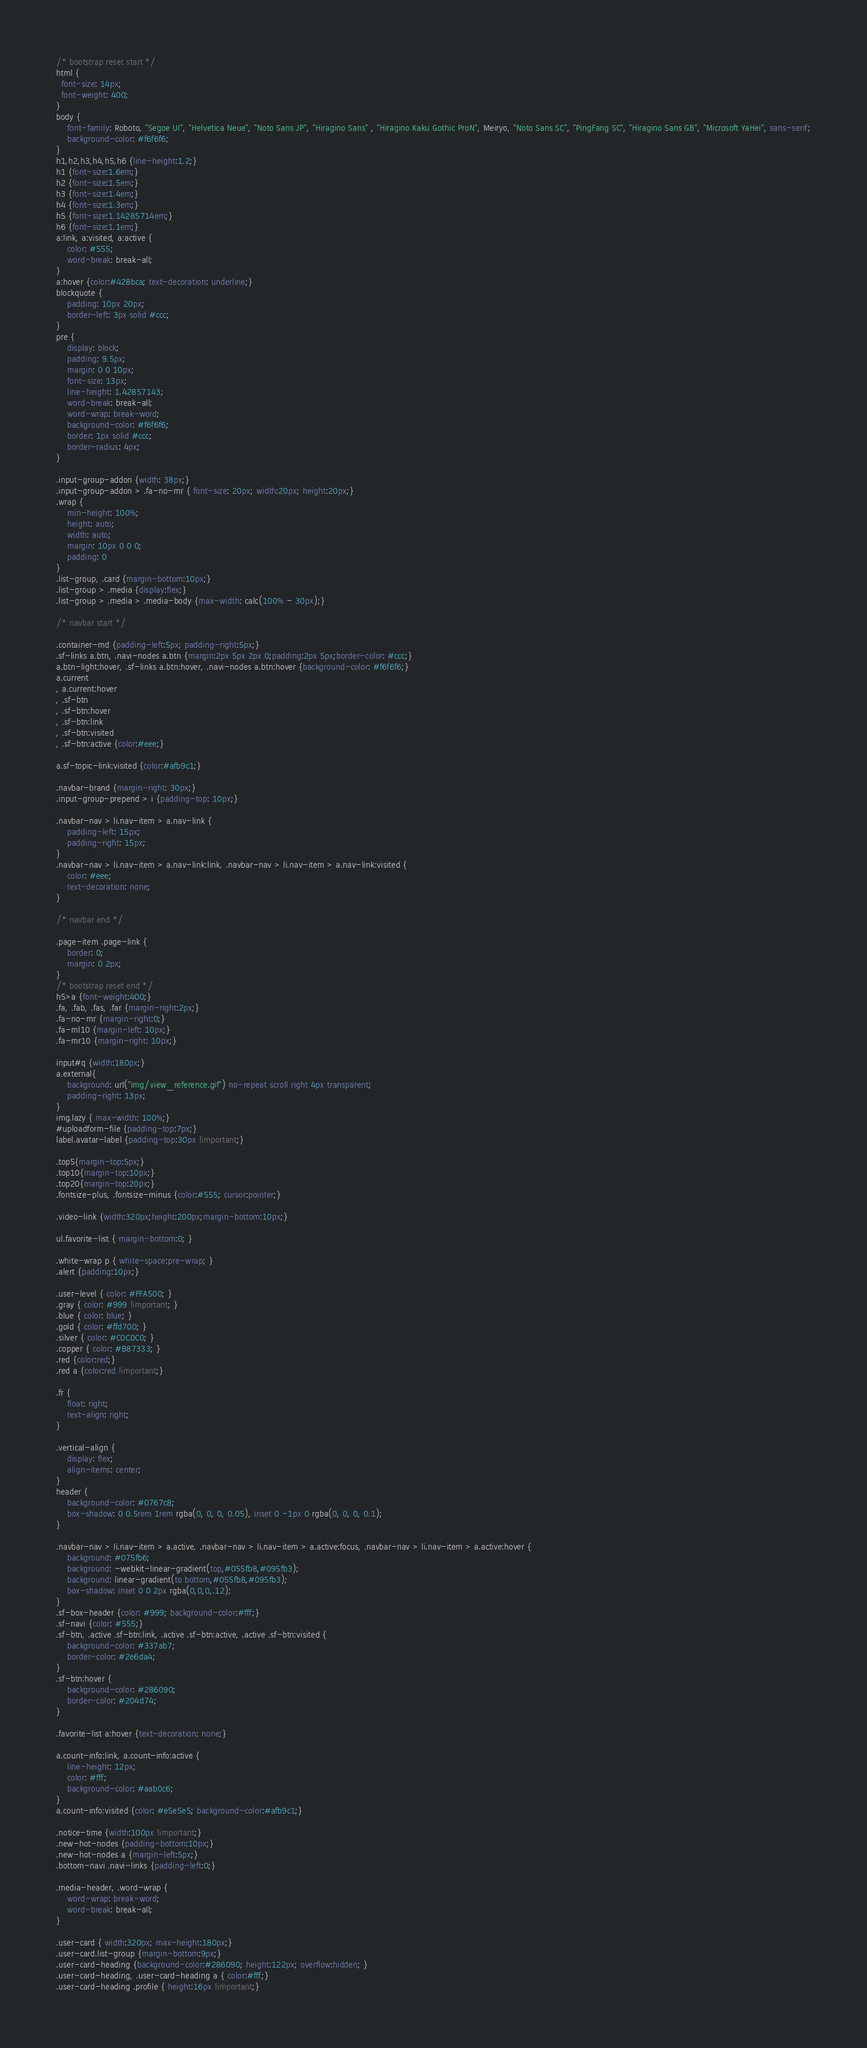<code> <loc_0><loc_0><loc_500><loc_500><_CSS_>/* bootstrap reset start */
html {
  font-size: 14px; 
  font-weight: 400; 
} 
body {
    font-family: Roboto, "Segoe UI", "Helvetica Neue", "Noto Sans JP", "Hiragino Sans" , "Hiragino Kaku Gothic ProN", Meiryo, "Noto Sans SC", "PingFang SC", "Hiragino Sans GB", "Microsoft YaHei", sans-serif;
    background-color: #f6f6f6;
}
h1,h2,h3,h4,h5,h6 {line-height:1.2;}
h1 {font-size:1.6em;}
h2 {font-size:1.5em;}
h3 {font-size:1.4em;}
h4 {font-size:1.3em;}
h5 {font-size:1.14285714em;}
h6 {font-size:1.1em;}
a:link, a:visited, a:active {
    color: #555;
    word-break: break-all;
}
a:hover {color:#428bca; text-decoration: underline;}
blockquote {
    padding: 10px 20px;
    border-left: 3px solid #ccc;
}
pre {
    display: block;
    padding: 9.5px;
    margin: 0 0 10px;
    font-size: 13px;
    line-height: 1.42857143;
    word-break: break-all;
    word-wrap: break-word;
    background-color: #f6f6f6;
    border: 1px solid #ccc;
    border-radius: 4px;
}

.input-group-addon {width: 38px;}
.input-group-addon > .fa-no-mr { font-size: 20px; width:20px; height:20px;}
.wrap {
    min-height: 100%;
    height: auto;
    width: auto;
    margin: 10px 0 0 0;
    padding: 0
}
.list-group, .card {margin-bottom:10px;}
.list-group > .media {display:flex;}
.list-group > .media > .media-body {max-width: calc(100% - 30px);}

/* navbar start */

.container-md {padding-left:5px; padding-right:5px;}
.sf-links a.btn, .navi-nodes a.btn {margin:2px 5px 2px 0;padding:2px 5px;border-color: #ccc;}
a.btn-light:hover, .sf-links a.btn:hover, .navi-nodes a.btn:hover {background-color: #f6f6f6;}
a.current
, a.current:hover
, .sf-btn
, .sf-btn:hover
, .sf-btn:link
, .sf-btn:visited
, .sf-btn:active {color:#eee;}

a.sf-topic-link:visited {color:#afb9c1;}

.navbar-brand {margin-right: 30px;}
.input-group-prepend > i {padding-top: 10px;}

.navbar-nav > li.nav-item > a.nav-link {
    padding-left: 15px;
    padding-right: 15px;
}
.navbar-nav > li.nav-item > a.nav-link:link, .navbar-nav > li.nav-item > a.nav-link:visited {
    color: #eee;
    text-decoration: none;
}

/* navbar end */

.page-item .page-link {
    border: 0;
    margin: 0 2px;
}
/* bootstrap reset end */
h5>a {font-weight:400;}
.fa, .fab, .fas, .far {margin-right:2px;}
.fa-no-mr {margin-right:0;}
.fa-ml10 {margin-left: 10px;}
.fa-mr10 {margin-right: 10px;}

input#q {width:180px;}
a.external{
    background: url("img/view_reference.gif") no-repeat scroll right 4px transparent;
    padding-right: 13px;
}
img.lazy { max-width: 100%;}
#uploadform-file {padding-top:7px;}
label.avatar-label {padding-top:30px !important;}

.top5{margin-top:5px;}
.top10{margin-top:10px;}
.top20{margin-top:20px;}
.fontsize-plus, .fontsize-minus {color:#555; cursor:pointer;}

.video-link {width:320px;height:200px;margin-bottom:10px;}

ul.favorite-list { margin-bottom:0; }

.white-wrap p { white-space:pre-wrap; }
.alert {padding:10px;}

.user-level { color: #FFA500; }
.gray { color: #999 !important; }
.blue { color: blue; }
.gold { color: #ffd700; }
.silver { color: #C0C0C0; }
.copper { color: #B87333; }
.red {color:red;}
.red a {color:red !important;}

.fr {
    float: right;
    text-align: right;
}

.vertical-align {
    display: flex;
    align-items: center;
}
header {
    background-color: #0767c8;
    box-shadow: 0 0.5rem 1rem rgba(0, 0, 0, 0.05), inset 0 -1px 0 rgba(0, 0, 0, 0.1);
}

.navbar-nav > li.nav-item > a.active, .navbar-nav > li.nav-item > a.active:focus, .navbar-nav > li.nav-item > a.active:hover {
    background: #075fb6;
    background: -webkit-linear-gradient(top,#055fb8,#095fb3);
    background: linear-gradient(to bottom,#055fb8,#095fb3);
    box-shadow: inset 0 0 2px rgba(0,0,0,.12);
}
.sf-box-header {color: #999; background-color:#fff;}
.sf-navi {color: #555;}
.sf-btn, .active .sf-btn:link, .active .sf-btn:active, .active .sf-btn:visited {
    background-color: #337ab7;
    border-color: #2e6da4;
}
.sf-btn:hover {
    background-color: #286090; 
    border-color: #204d74;
}

.favorite-list a:hover {text-decoration: none;}

a.count-info:link, a.count-info:active {
    line-height: 12px;
    color: #fff;
    background-color: #aab0c6;
}
a.count-info:visited {color: #e5e5e5; background-color:#afb9c1;}

.notice-time {width:100px !important;}
.new-hot-nodes {padding-bottom:10px;}
.new-hot-nodes a {margin-left:5px;}
.bottom-navi .navi-links {padding-left:0;}

.media-header, .word-wrap {
    word-wrap: break-word; 
    word-break: break-all;
}

.user-card { width:320px; max-height:180px;}
.user-card.list-group {margin-bottom:9px;}
.user-card-heading {background-color:#286090; height:122px; overflow:hidden; }
.user-card-heading, .user-card-heading a { color:#fff;}
.user-card-heading .profile { height:16px !important;}</code> 